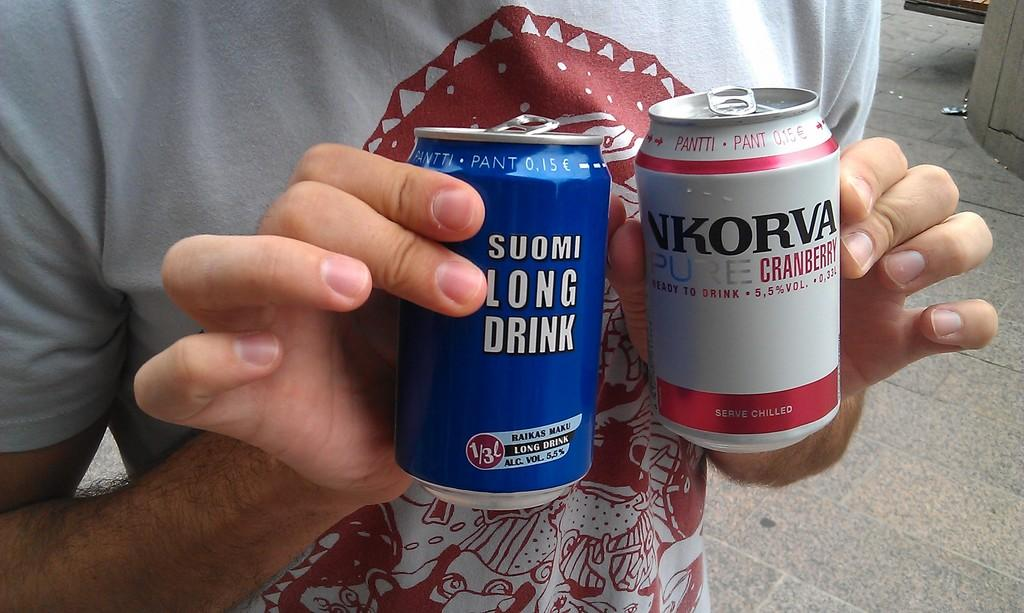Provide a one-sentence caption for the provided image. Person holding a blue Suomi Long Drink and a white NKorva Cranberry drink. 